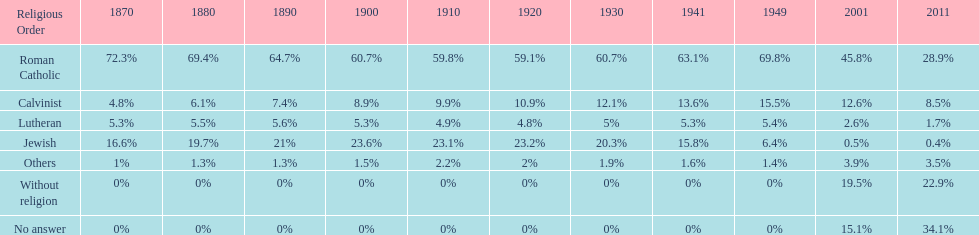What is the total percentage of people who identified as religious in 2011? 43%. 